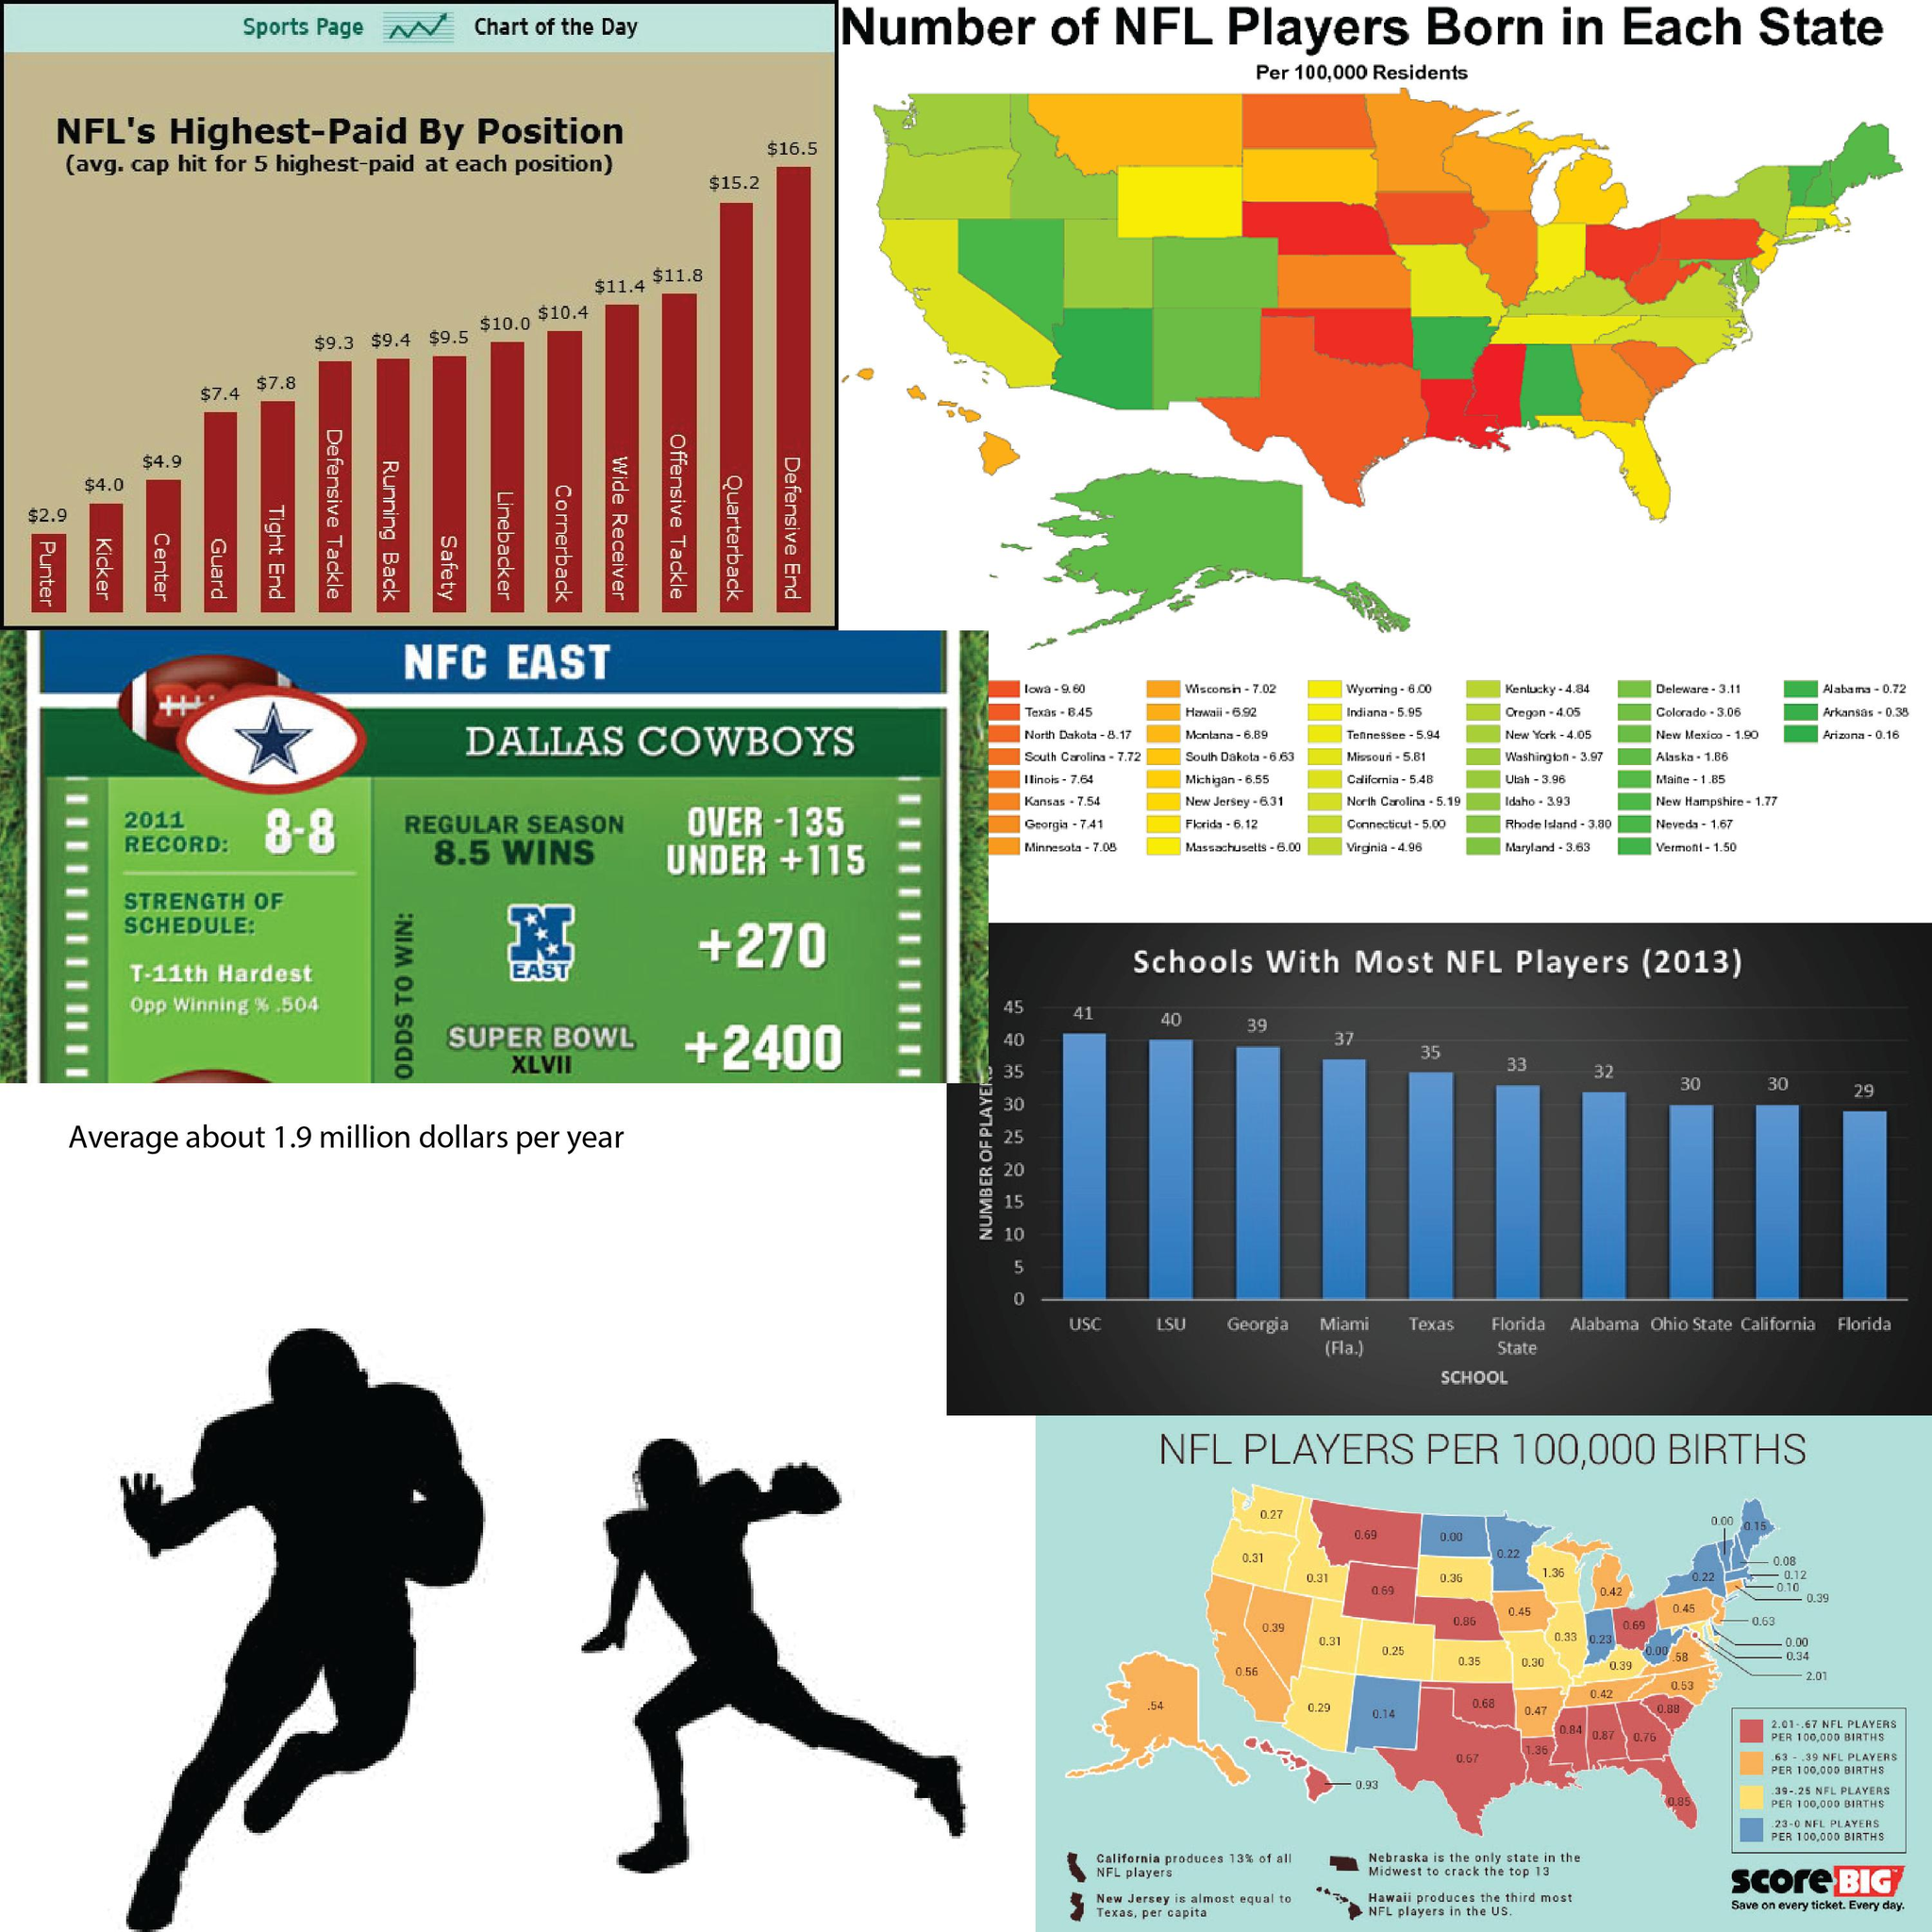Give some essential details in this illustration. Arizona has the lowest number of NFL players born per 100,000 residents among all U.S. states. Quarterback is the second-highest paid position in the National Football League (NFL). According to the information provided, in 2013, LSU produced the second-highest number of NFL players. The state with the highest number of NFL players born per 100,000 residents is Iowa. Out of every 100,000 residents in Hawaii, approximately 6.92 NFL players are born in the state. 